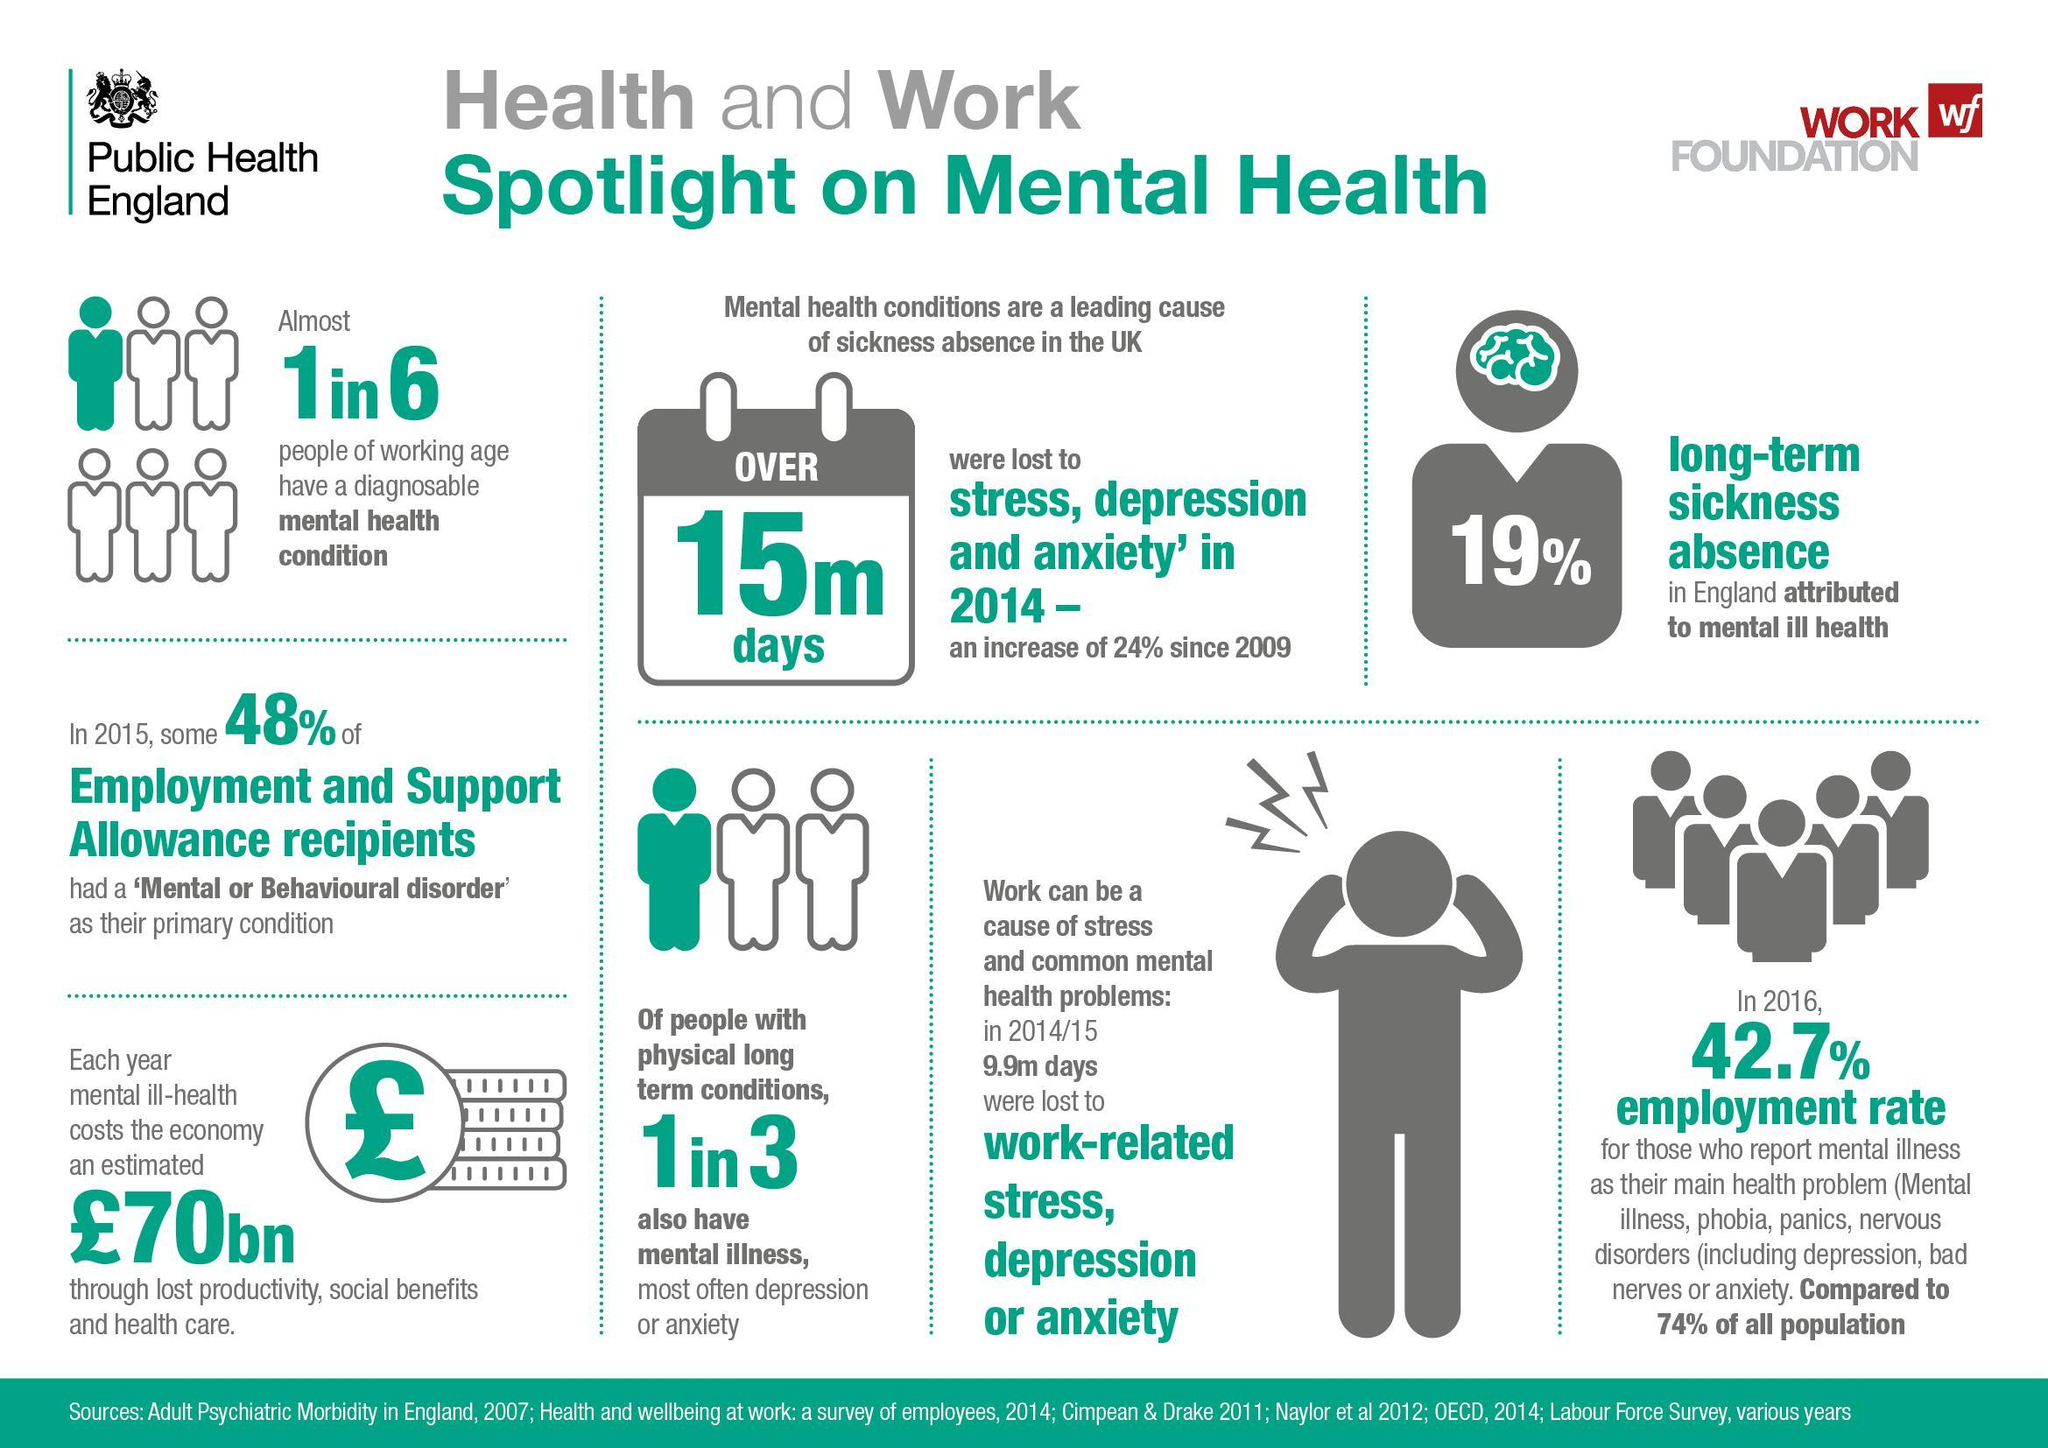What is written on the calender
Answer the question with a short phrase. over 15m days How many days are lost due to mental health conditions in 2014 15m how is the economy loosing 70bn pounds yearly due to mental ill-health through lost productivity, social benefits and health care how many days were lost in 2014/15 due to work-related stress, depression or anxiety 9.9 How many people among those with physical long term conditions also have mental illness 1 in 3 what is the colour of the brain, yellow or green green 